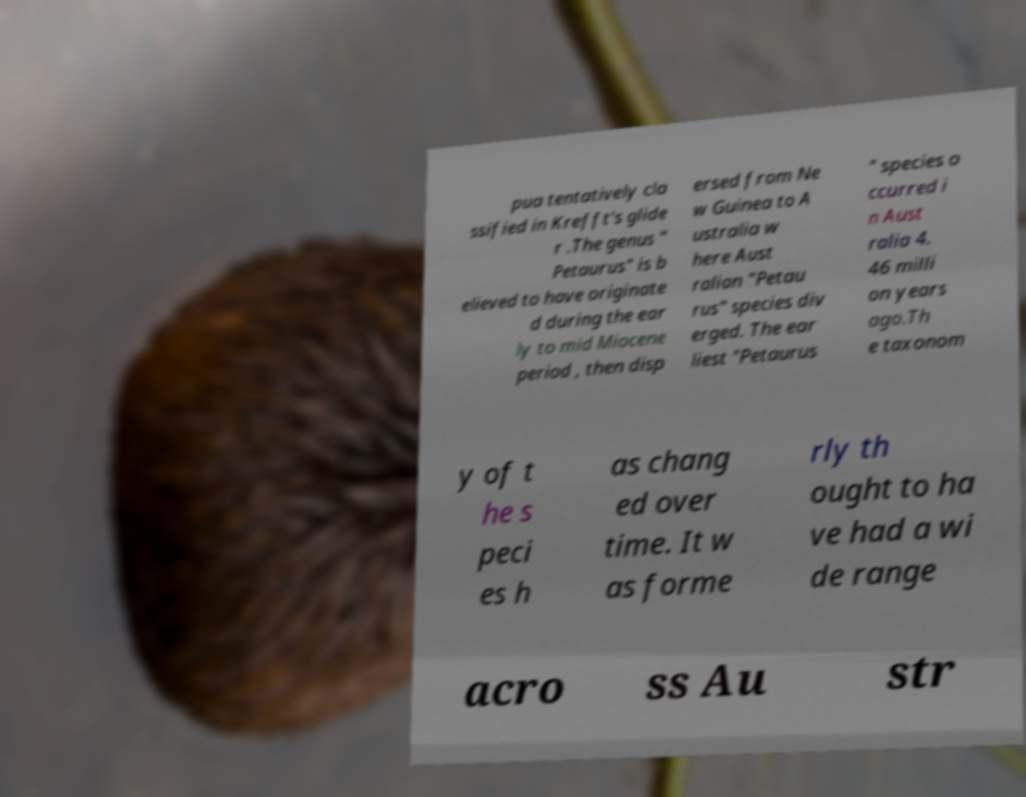For documentation purposes, I need the text within this image transcribed. Could you provide that? pua tentatively cla ssified in Krefft's glide r .The genus " Petaurus" is b elieved to have originate d during the ear ly to mid Miocene period , then disp ersed from Ne w Guinea to A ustralia w here Aust ralian "Petau rus" species div erged. The ear liest "Petaurus " species o ccurred i n Aust ralia 4. 46 milli on years ago.Th e taxonom y of t he s peci es h as chang ed over time. It w as forme rly th ought to ha ve had a wi de range acro ss Au str 